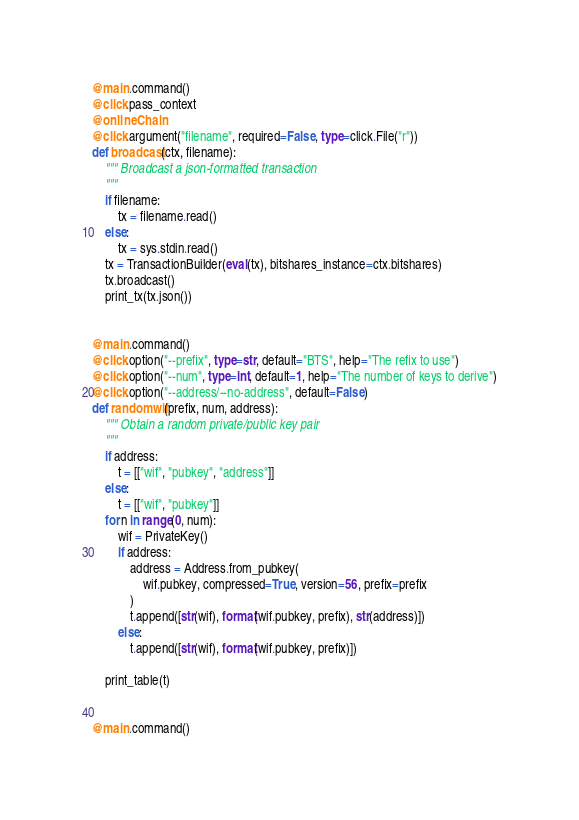Convert code to text. <code><loc_0><loc_0><loc_500><loc_500><_Python_>
@main.command()
@click.pass_context
@onlineChain
@click.argument("filename", required=False, type=click.File("r"))
def broadcast(ctx, filename):
    """ Broadcast a json-formatted transaction
    """
    if filename:
        tx = filename.read()
    else:
        tx = sys.stdin.read()
    tx = TransactionBuilder(eval(tx), bitshares_instance=ctx.bitshares)
    tx.broadcast()
    print_tx(tx.json())


@main.command()
@click.option("--prefix", type=str, default="BTS", help="The refix to use")
@click.option("--num", type=int, default=1, help="The number of keys to derive")
@click.option("--address/--no-address", default=False)
def randomwif(prefix, num, address):
    """ Obtain a random private/public key pair
    """
    if address:
        t = [["wif", "pubkey", "address"]]
    else:
        t = [["wif", "pubkey"]]
    for n in range(0, num):
        wif = PrivateKey()
        if address:
            address = Address.from_pubkey(
                wif.pubkey, compressed=True, version=56, prefix=prefix
            )
            t.append([str(wif), format(wif.pubkey, prefix), str(address)])
        else:
            t.append([str(wif), format(wif.pubkey, prefix)])

    print_table(t)


@main.command()</code> 